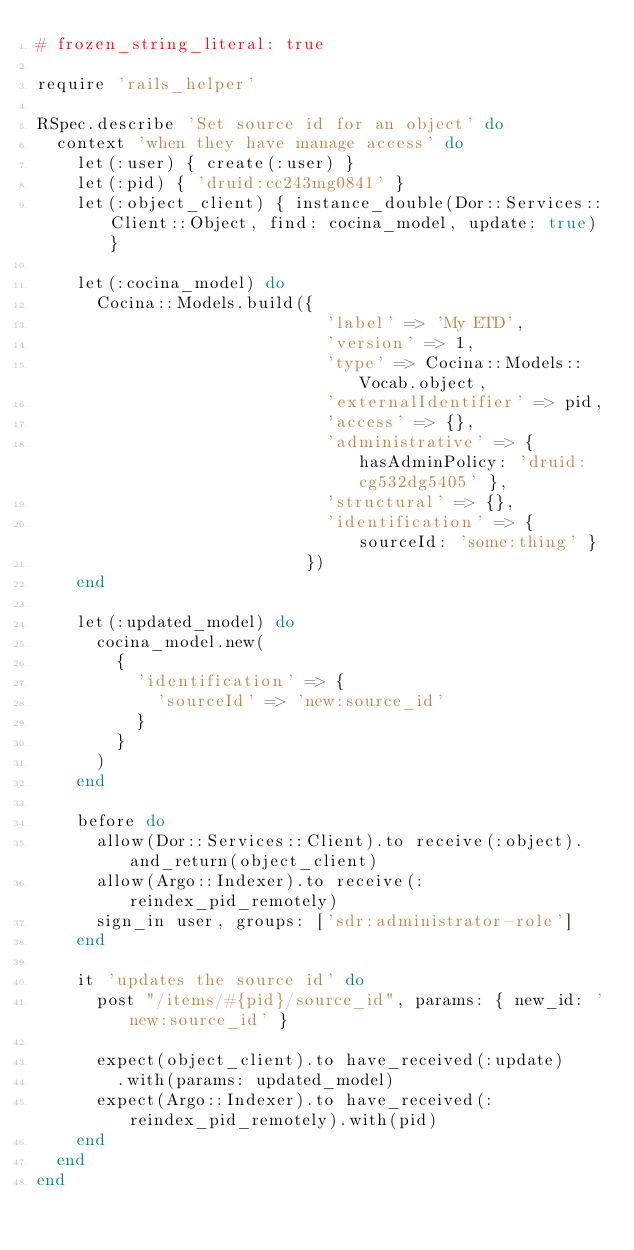<code> <loc_0><loc_0><loc_500><loc_500><_Ruby_># frozen_string_literal: true

require 'rails_helper'

RSpec.describe 'Set source id for an object' do
  context 'when they have manage access' do
    let(:user) { create(:user) }
    let(:pid) { 'druid:cc243mg0841' }
    let(:object_client) { instance_double(Dor::Services::Client::Object, find: cocina_model, update: true) }

    let(:cocina_model) do
      Cocina::Models.build({
                             'label' => 'My ETD',
                             'version' => 1,
                             'type' => Cocina::Models::Vocab.object,
                             'externalIdentifier' => pid,
                             'access' => {},
                             'administrative' => { hasAdminPolicy: 'druid:cg532dg5405' },
                             'structural' => {},
                             'identification' => { sourceId: 'some:thing' }
                           })
    end

    let(:updated_model) do
      cocina_model.new(
        {
          'identification' => {
            'sourceId' => 'new:source_id'
          }
        }
      )
    end

    before do
      allow(Dor::Services::Client).to receive(:object).and_return(object_client)
      allow(Argo::Indexer).to receive(:reindex_pid_remotely)
      sign_in user, groups: ['sdr:administrator-role']
    end

    it 'updates the source id' do
      post "/items/#{pid}/source_id", params: { new_id: 'new:source_id' }

      expect(object_client).to have_received(:update)
        .with(params: updated_model)
      expect(Argo::Indexer).to have_received(:reindex_pid_remotely).with(pid)
    end
  end
end
</code> 